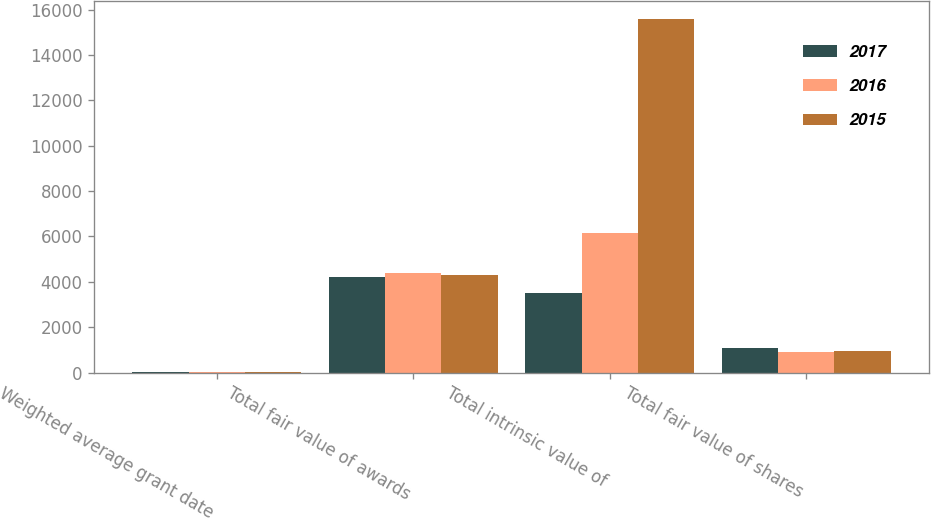Convert chart to OTSL. <chart><loc_0><loc_0><loc_500><loc_500><stacked_bar_chart><ecel><fcel>Weighted average grant date<fcel>Total fair value of awards<fcel>Total intrinsic value of<fcel>Total fair value of shares<nl><fcel>2017<fcel>8.55<fcel>4203<fcel>3497<fcel>1087<nl><fcel>2016<fcel>5.68<fcel>4407<fcel>6170<fcel>923<nl><fcel>2015<fcel>5.6<fcel>4290<fcel>15585<fcel>951<nl></chart> 